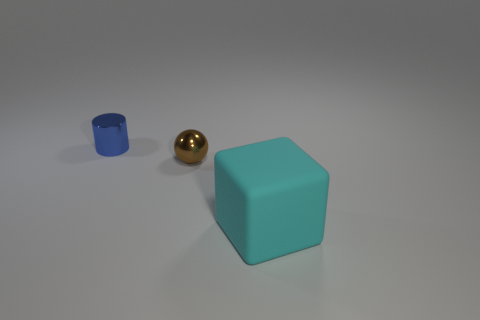Describe the lighting in the scene and how it affects the appearance of the objects. The lighting in the scene appears to be soft and diffused, coming from above. It casts gentle shadows directly beneath the objects, enhancing their three-dimensional form. The subtle nature of the light creates a serene atmosphere and allows the colors of the objects to remain true and vibrant. 